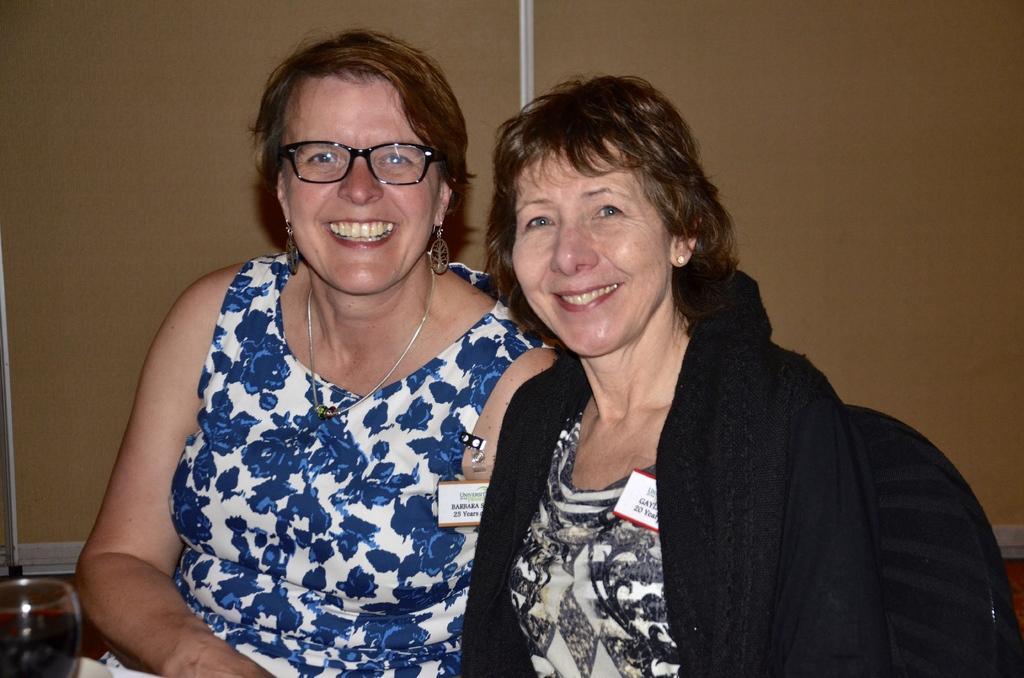Could you give a brief overview of what you see in this image? In this image in the foregrounds there are two women who are sitting and smiling, and in the background there are some boards. And at the bottom there is glass, and in the glass there is some drink. 